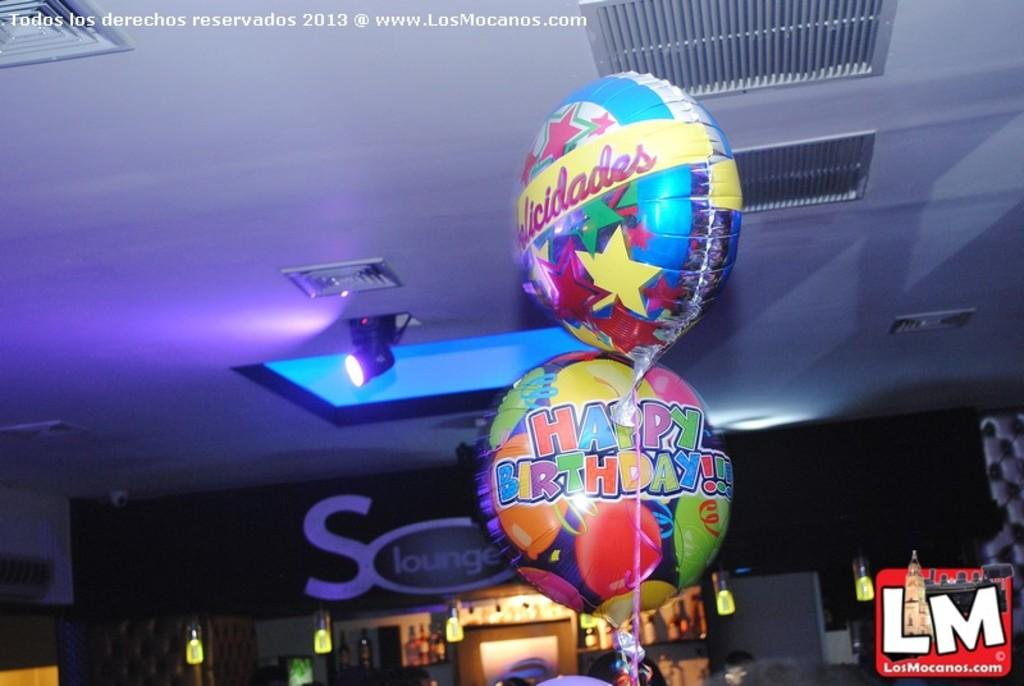What type of structure can be seen in the image? There is a wall in the image. What can be used for illumination in the image? There are lights in the image. What type of decorative items are present in the image? There are balloons in the image. What type of architectural feature is present in the image? There is a door in the image. Can you see any ocean waves in the image? There is no reference to an ocean or waves in the image. What type of vegetable is growing in the jar in the image? There is no jar or vegetable present in the image. 